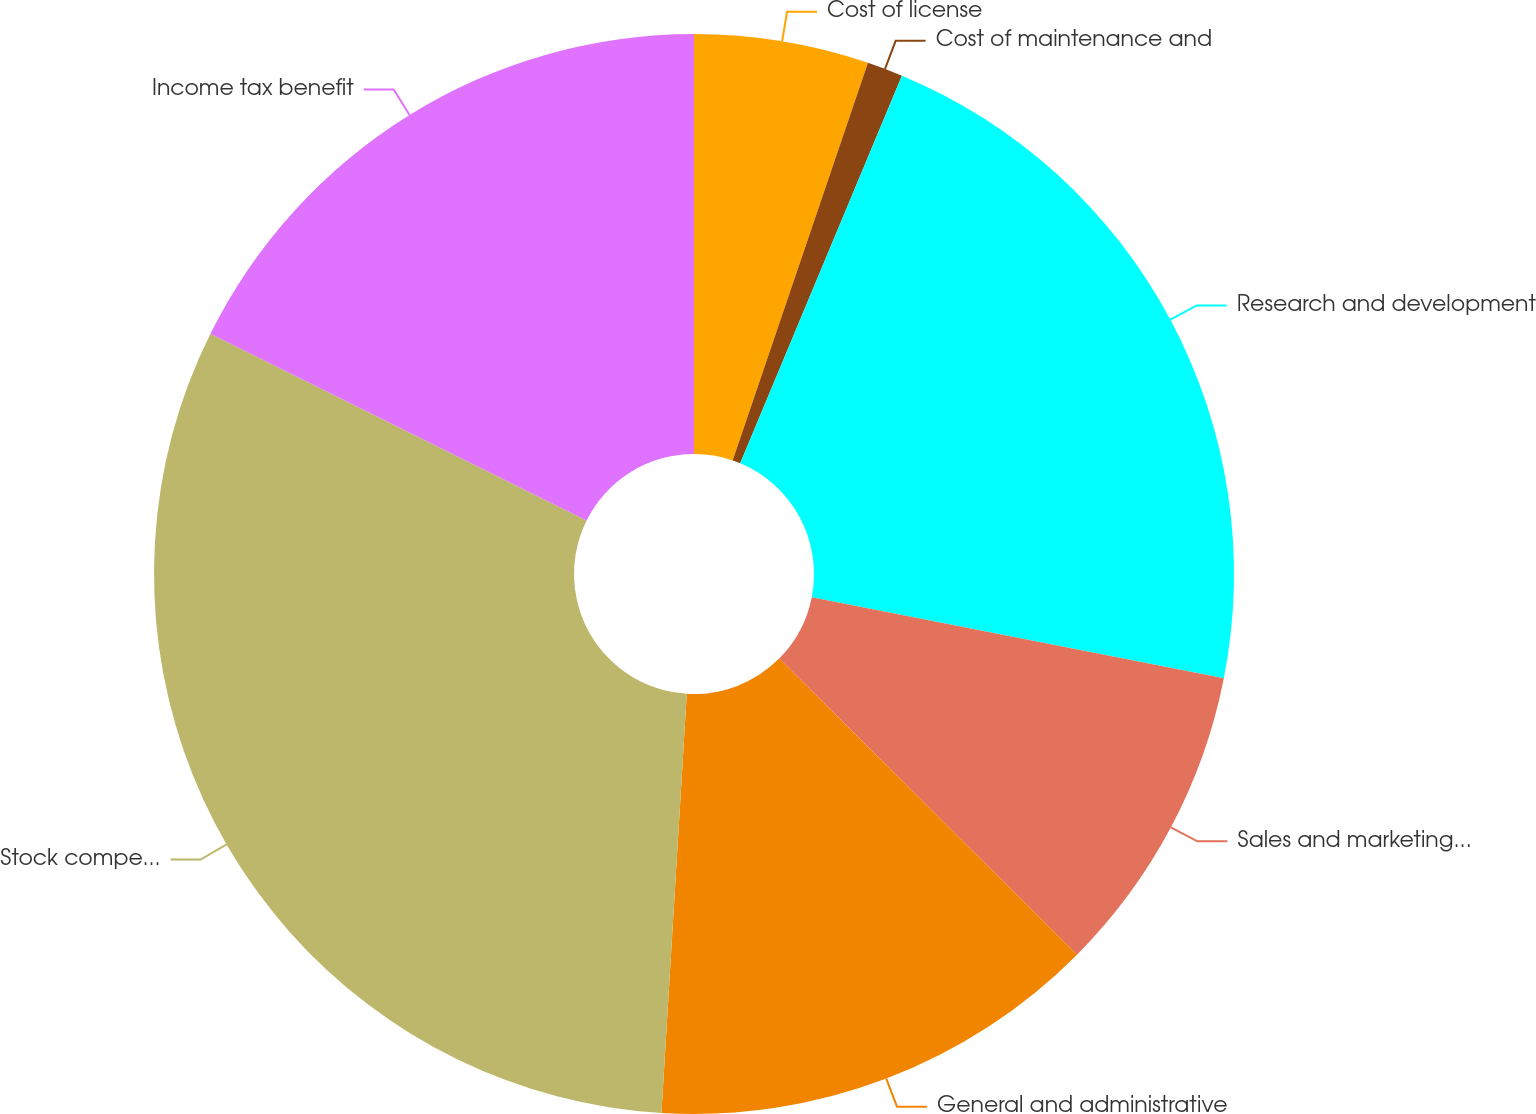Convert chart to OTSL. <chart><loc_0><loc_0><loc_500><loc_500><pie_chart><fcel>Cost of license<fcel>Cost of maintenance and<fcel>Research and development<fcel>Sales and marketing expense<fcel>General and administrative<fcel>Stock compensation expense<fcel>Income tax benefit<nl><fcel>5.22%<fcel>1.07%<fcel>21.8%<fcel>9.36%<fcel>13.51%<fcel>31.38%<fcel>17.66%<nl></chart> 